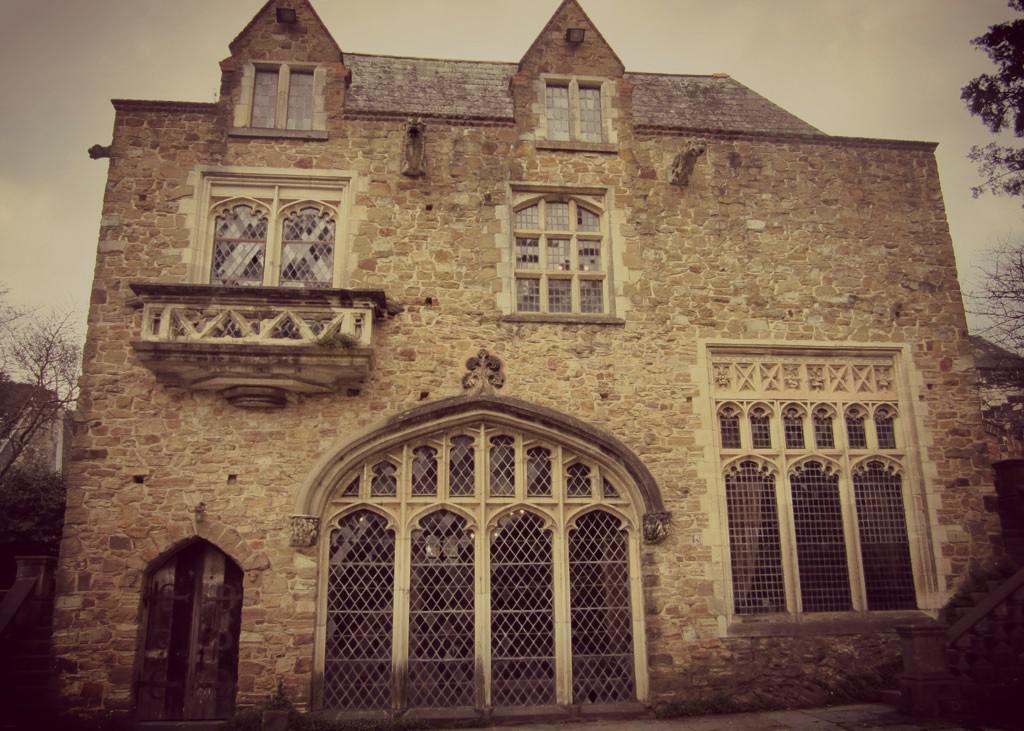In one or two sentences, can you explain what this image depicts? In the foreground of this image, there is a building and on either side, there are trees. At the top, there is the sky. 